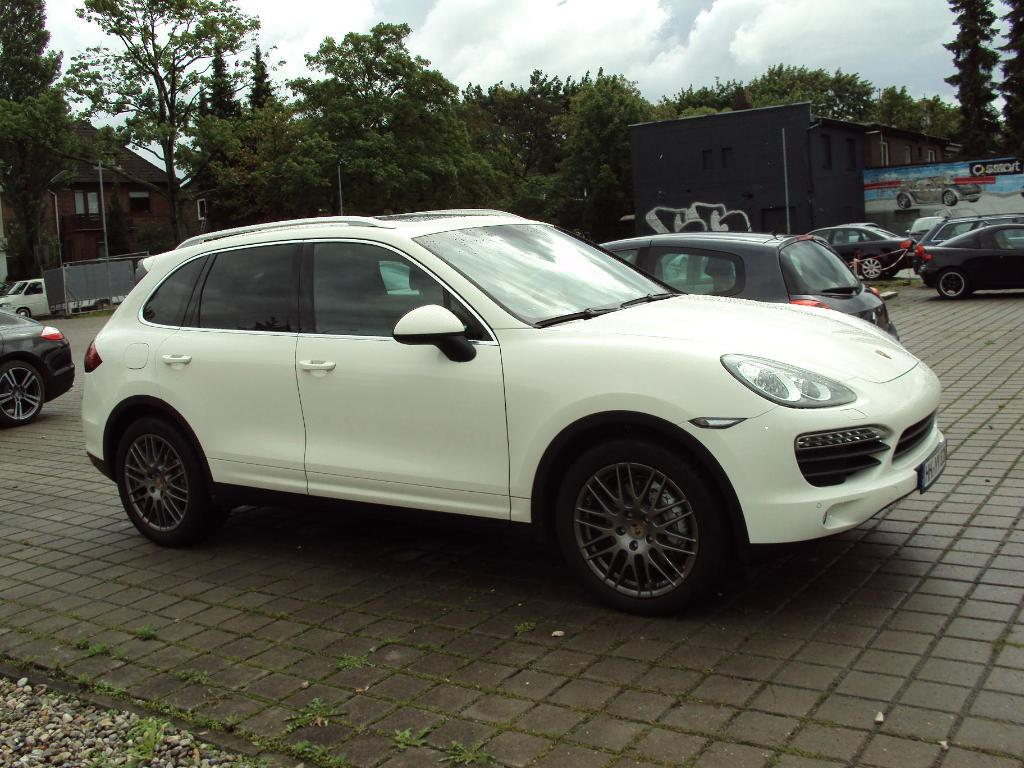What type of vehicles can be seen in the image? There are cars in the image. What structures are present in the image? There are poles, houses, and a hoarding in the image. What type of vegetation is visible in the image? There are trees in the image. What is visible in the background of the image? The sky is visible in the background of the image, and there are clouds in the sky. Can you tell me how the army is pulling the cars in the image? There is no army or any indication of cars being pulled in the image. The image only shows cars, poles, trees, a hoarding, houses, and the sky with clouds. 